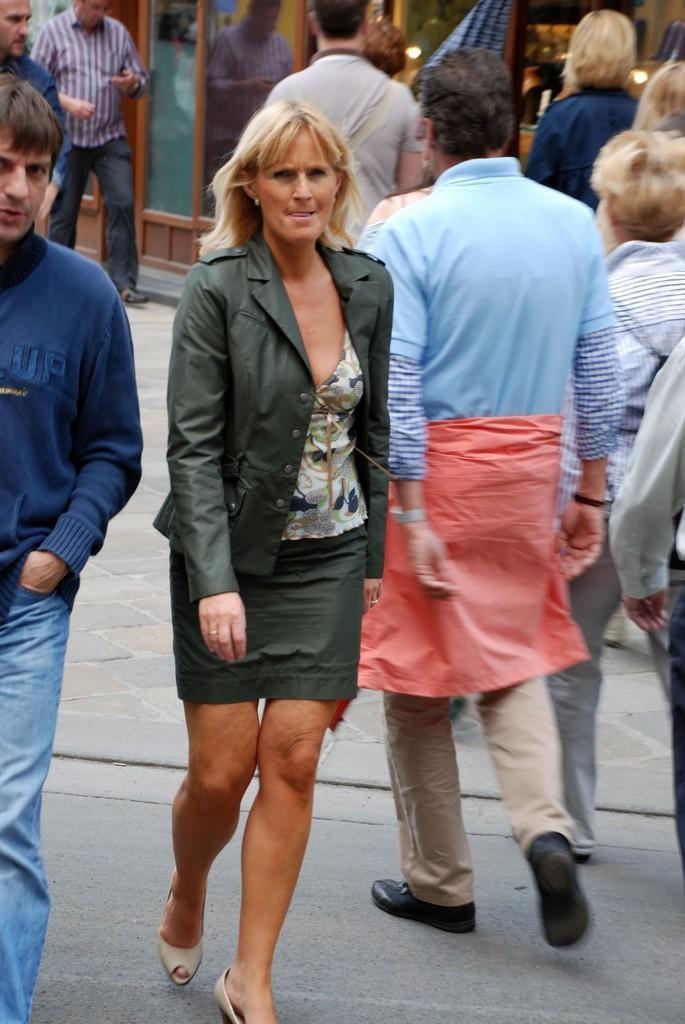How would you summarize this image in a sentence or two? In this picture we can see some people walking, in the background there is a glass, we can see reflection of this person on the glass. 